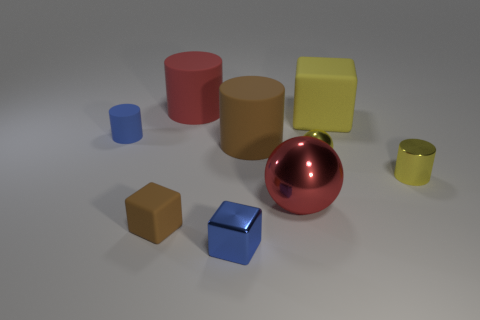There is a big cylinder that is the same color as the tiny matte cube; what is its material?
Keep it short and to the point. Rubber. There is a rubber thing that is behind the yellow matte thing; is its shape the same as the brown thing that is in front of the red shiny object?
Give a very brief answer. No. How many spheres are brown shiny things or blue matte things?
Give a very brief answer. 0. Are there fewer blue cylinders right of the big ball than yellow spheres?
Make the answer very short. Yes. What number of other things are the same material as the big brown cylinder?
Give a very brief answer. 4. Is the yellow rubber object the same size as the yellow cylinder?
Provide a succinct answer. No. What number of things are either metallic objects to the right of the large metallic sphere or blue matte cylinders?
Offer a very short reply. 3. What material is the sphere that is right of the metal sphere in front of the metallic cylinder made of?
Make the answer very short. Metal. Are there any other tiny rubber objects that have the same shape as the small brown thing?
Offer a very short reply. No. Does the metallic cube have the same size as the cylinder behind the blue cylinder?
Your answer should be very brief. No. 